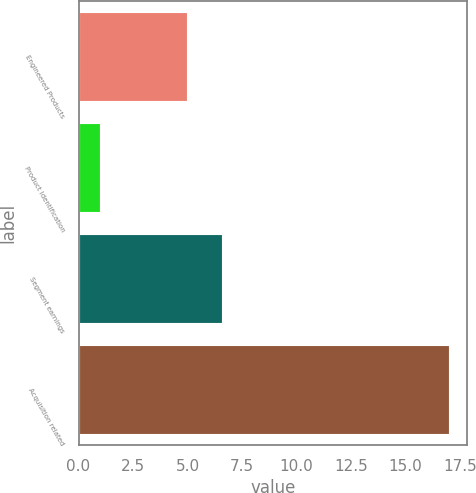<chart> <loc_0><loc_0><loc_500><loc_500><bar_chart><fcel>Engineered Products<fcel>Product Identification<fcel>Segment earnings<fcel>Acquisition related<nl><fcel>5<fcel>1<fcel>6.6<fcel>17<nl></chart> 